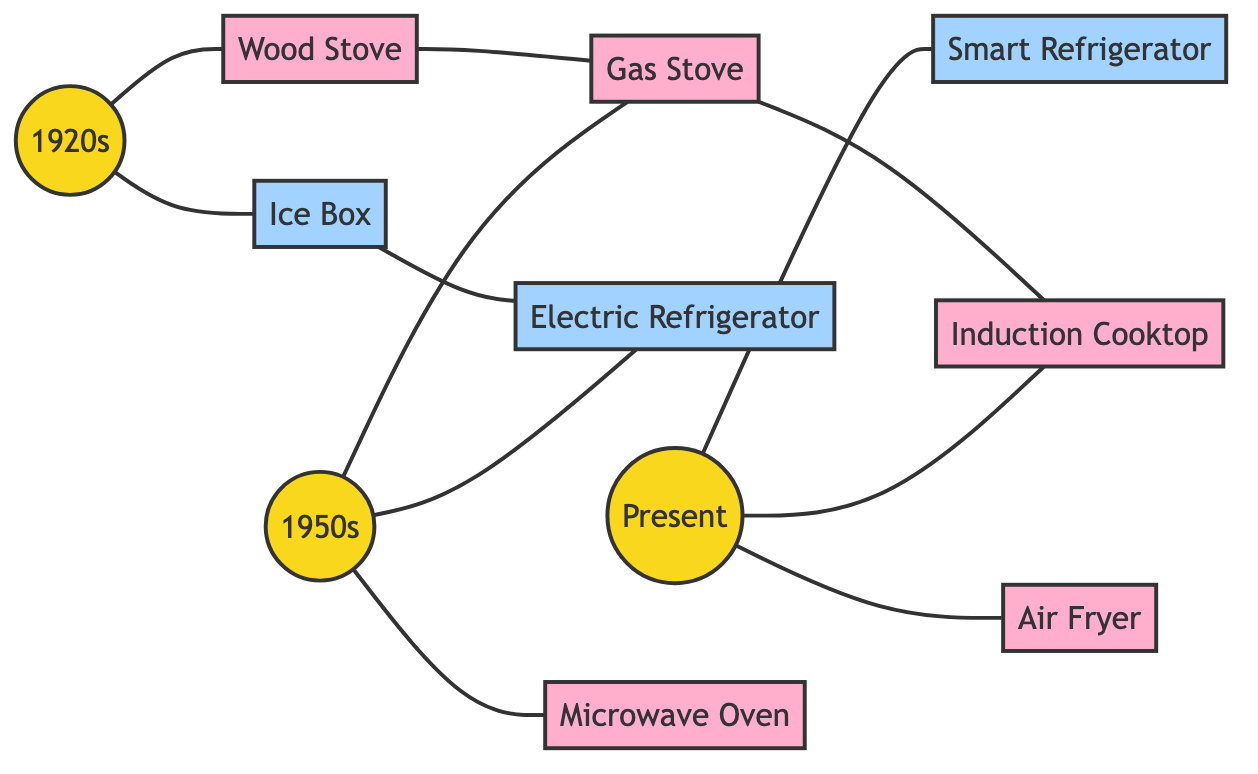What era is associated with the Ice Box? The diagram connects the Ice Box to the 1920s, indicating that it was prevalent in that era. Therefore, the Ice Box is linked to the 1920s.
Answer: 1920s How many cooking appliances are shown in the diagram? The diagram lists five cooking appliances: Wood Stove, Gas Stove, Microwave Oven, Induction Cooktop, and Air Fryer. Counting these gives us a total of five cooking appliances.
Answer: 5 Which appliance is directly connected to the Gas Stove? The edges in the diagram show that the Gas Stove has a direct connection to the Induction Cooktop. This indicates a direct relationship between these two appliances.
Answer: Induction Cooktop What is the relationship between the Electric Refrigerator and the Ice Box? The diagram illustrates a connection where Electric Refrigerator is directly linked to Ice Box, suggesting that the Electric Refrigerator replaced the Ice Box as it evolved.
Answer: Replacement Which decade introduced the Microwave Oven? The connection from the 1950s directly to the Microwave Oven in the diagram indicates that this appliance was introduced during that decade.
Answer: 1950s What is the total number of nodes in the graph? The diagram lists a total of ten nodes: three eras (1920s, 1950s, Present) and seven appliances (Ice Box, Wood Stove, Electric Refrigerator, Gas Stove, Microwave Oven, Smart Refrigerator, Induction Cooktop, Air Fryer). Counting these yields a total of ten nodes.
Answer: 10 Which appliance evolved from the Wood Stove? The Wood Stove connects directly to the Gas Stove in the diagram, indicating that the Gas Stove is the appliance that evolved from the Wood Stove as cooking technology progressed.
Answer: Gas Stove Which era does the Smart Refrigerator belong to? The diagram shows that the Smart Refrigerator is connected to the Present node, indicating that it is a modern appliance of the current era.
Answer: Present 